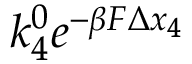<formula> <loc_0><loc_0><loc_500><loc_500>k _ { 4 } ^ { 0 } e ^ { - \beta F \Delta x _ { 4 } }</formula> 